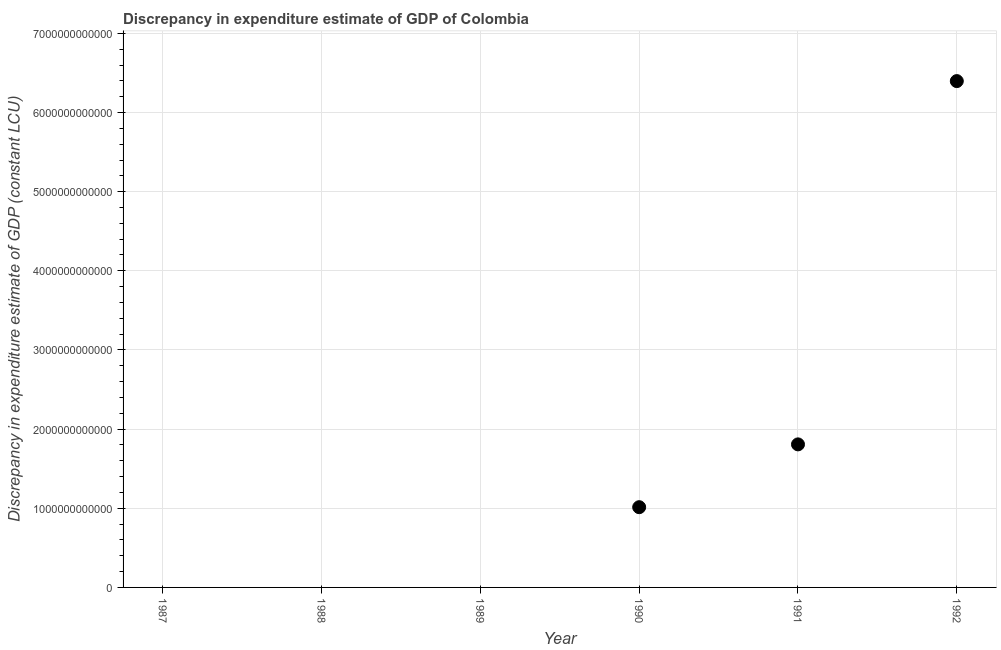What is the discrepancy in expenditure estimate of gdp in 1992?
Offer a very short reply. 6.40e+12. Across all years, what is the maximum discrepancy in expenditure estimate of gdp?
Offer a terse response. 6.40e+12. What is the sum of the discrepancy in expenditure estimate of gdp?
Your response must be concise. 9.22e+12. What is the difference between the discrepancy in expenditure estimate of gdp in 1990 and 1991?
Make the answer very short. -7.94e+11. What is the average discrepancy in expenditure estimate of gdp per year?
Offer a very short reply. 1.54e+12. What is the median discrepancy in expenditure estimate of gdp?
Provide a succinct answer. 5.07e+11. What is the difference between the highest and the second highest discrepancy in expenditure estimate of gdp?
Make the answer very short. 4.59e+12. What is the difference between the highest and the lowest discrepancy in expenditure estimate of gdp?
Provide a succinct answer. 6.40e+12. In how many years, is the discrepancy in expenditure estimate of gdp greater than the average discrepancy in expenditure estimate of gdp taken over all years?
Your answer should be very brief. 2. Does the discrepancy in expenditure estimate of gdp monotonically increase over the years?
Your response must be concise. No. What is the difference between two consecutive major ticks on the Y-axis?
Provide a succinct answer. 1.00e+12. Are the values on the major ticks of Y-axis written in scientific E-notation?
Ensure brevity in your answer.  No. What is the title of the graph?
Make the answer very short. Discrepancy in expenditure estimate of GDP of Colombia. What is the label or title of the Y-axis?
Make the answer very short. Discrepancy in expenditure estimate of GDP (constant LCU). What is the Discrepancy in expenditure estimate of GDP (constant LCU) in 1987?
Ensure brevity in your answer.  0. What is the Discrepancy in expenditure estimate of GDP (constant LCU) in 1988?
Make the answer very short. 0. What is the Discrepancy in expenditure estimate of GDP (constant LCU) in 1989?
Provide a short and direct response. 0. What is the Discrepancy in expenditure estimate of GDP (constant LCU) in 1990?
Provide a short and direct response. 1.01e+12. What is the Discrepancy in expenditure estimate of GDP (constant LCU) in 1991?
Offer a terse response. 1.81e+12. What is the Discrepancy in expenditure estimate of GDP (constant LCU) in 1992?
Your answer should be very brief. 6.40e+12. What is the difference between the Discrepancy in expenditure estimate of GDP (constant LCU) in 1990 and 1991?
Give a very brief answer. -7.94e+11. What is the difference between the Discrepancy in expenditure estimate of GDP (constant LCU) in 1990 and 1992?
Offer a terse response. -5.38e+12. What is the difference between the Discrepancy in expenditure estimate of GDP (constant LCU) in 1991 and 1992?
Offer a terse response. -4.59e+12. What is the ratio of the Discrepancy in expenditure estimate of GDP (constant LCU) in 1990 to that in 1991?
Provide a succinct answer. 0.56. What is the ratio of the Discrepancy in expenditure estimate of GDP (constant LCU) in 1990 to that in 1992?
Provide a short and direct response. 0.16. What is the ratio of the Discrepancy in expenditure estimate of GDP (constant LCU) in 1991 to that in 1992?
Ensure brevity in your answer.  0.28. 